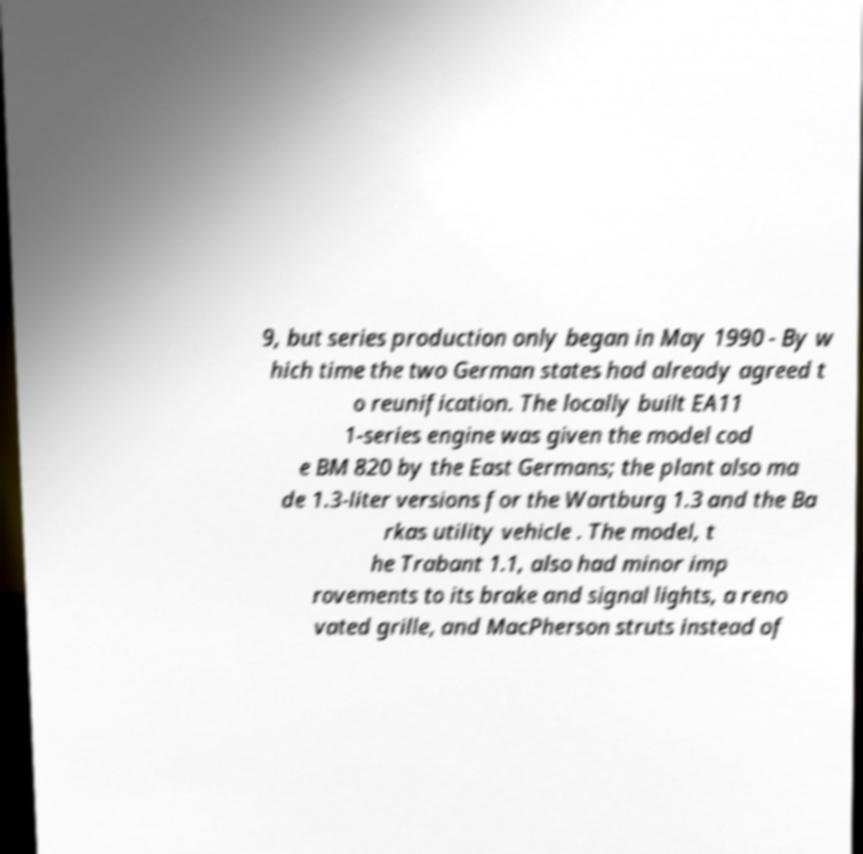Can you accurately transcribe the text from the provided image for me? 9, but series production only began in May 1990 - By w hich time the two German states had already agreed t o reunification. The locally built EA11 1-series engine was given the model cod e BM 820 by the East Germans; the plant also ma de 1.3-liter versions for the Wartburg 1.3 and the Ba rkas utility vehicle . The model, t he Trabant 1.1, also had minor imp rovements to its brake and signal lights, a reno vated grille, and MacPherson struts instead of 